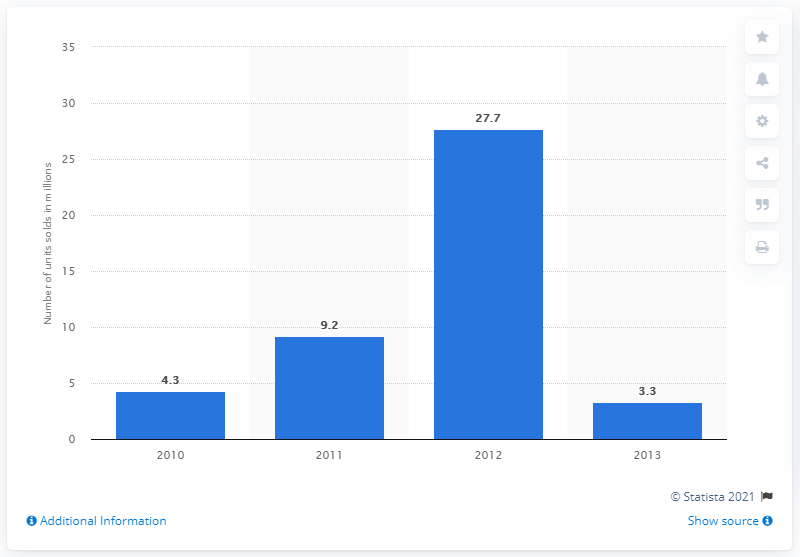Draw attention to some important aspects in this diagram. In 2010, a total of 4.3 million copies of "The Hunger Games" were sold in the United States. 